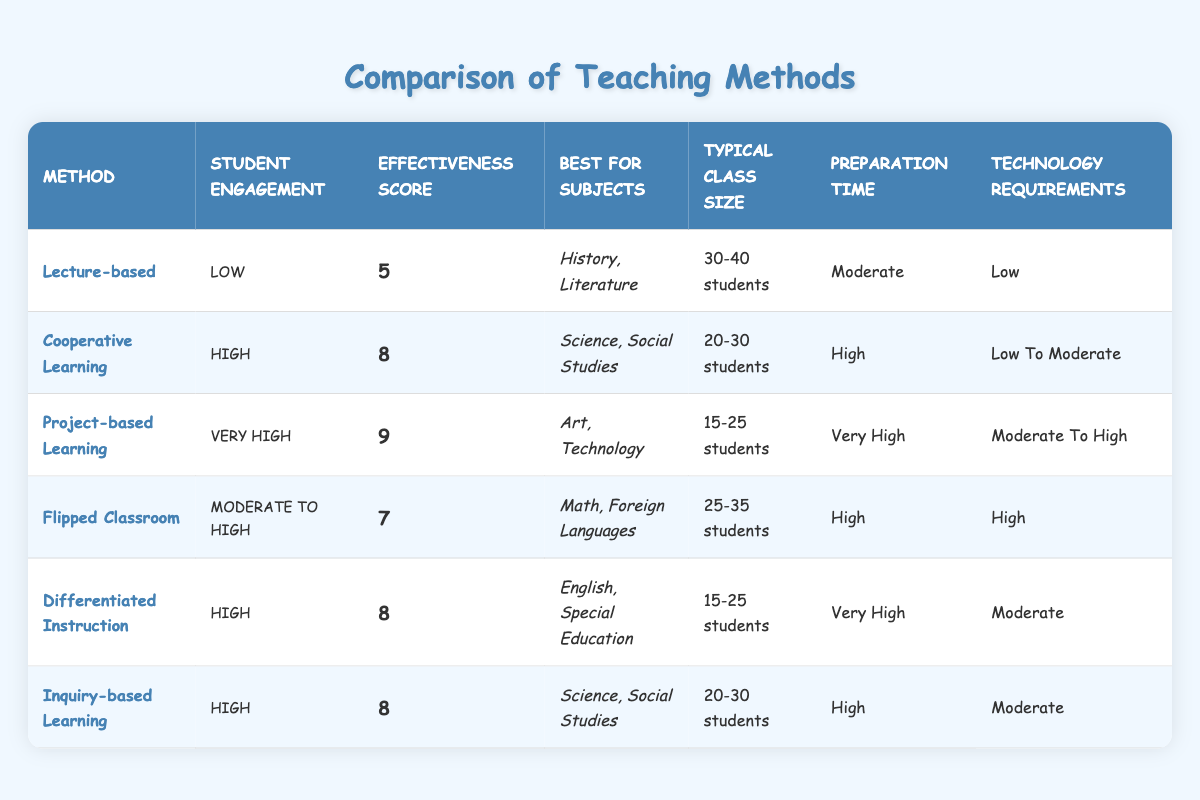What is the effectiveness score of Project-based Learning? According to the table, Project-based Learning has an effectiveness score listed as 9.
Answer: 9 Which teaching method has the highest student engagement? The table indicates that Project-based Learning has the highest student engagement, categorized as "Very High."
Answer: Project-based Learning What subjects are best for Cooperative Learning? The best subjects for Cooperative Learning, according to the table, are Science and Social Studies.
Answer: Science, Social Studies Is there a teaching method with Low technology requirements that also has a High effectiveness score? Examining the table, Cooperative Learning is the only method with Low to Moderate technology requirements and an effectiveness score of 8; therefore, the answer is “yes.”
Answer: Yes What is the typical class size range for Flipped Classroom? The table specifies that the typical class size for Flipped Classroom is 25-35 students.
Answer: 25-35 students If we combine the effectiveness scores of all teaching methods, what is the total? Adding the effectiveness scores: 5 (Lecture-based) + 8 (Cooperative Learning) + 9 (Project-based Learning) + 7 (Flipped Classroom) + 8 (Differentiated Instruction) + 8 (Inquiry-based Learning) equals a total of 45.
Answer: 45 What teaching methods have a High student engagement rating? Reviewing the table, Cooperative Learning, Differentiated Instruction, and Inquiry-based Learning each have a student engagement rating listed as High.
Answer: Cooperative Learning, Differentiated Instruction, Inquiry-based Learning How many teaching methods are categorized under Moderate to High student engagement? The table shows that there is one teaching method, the Flipped Classroom, categorized under Moderate to High engagement.
Answer: 1 Do any teaching methods rated with an effectiveness score over 8 require Very High preparation time? According to the table, Project-based Learning is rated with an effectiveness score of 9 and has Very High preparation time. Hence, the answer is “yes.”
Answer: Yes 